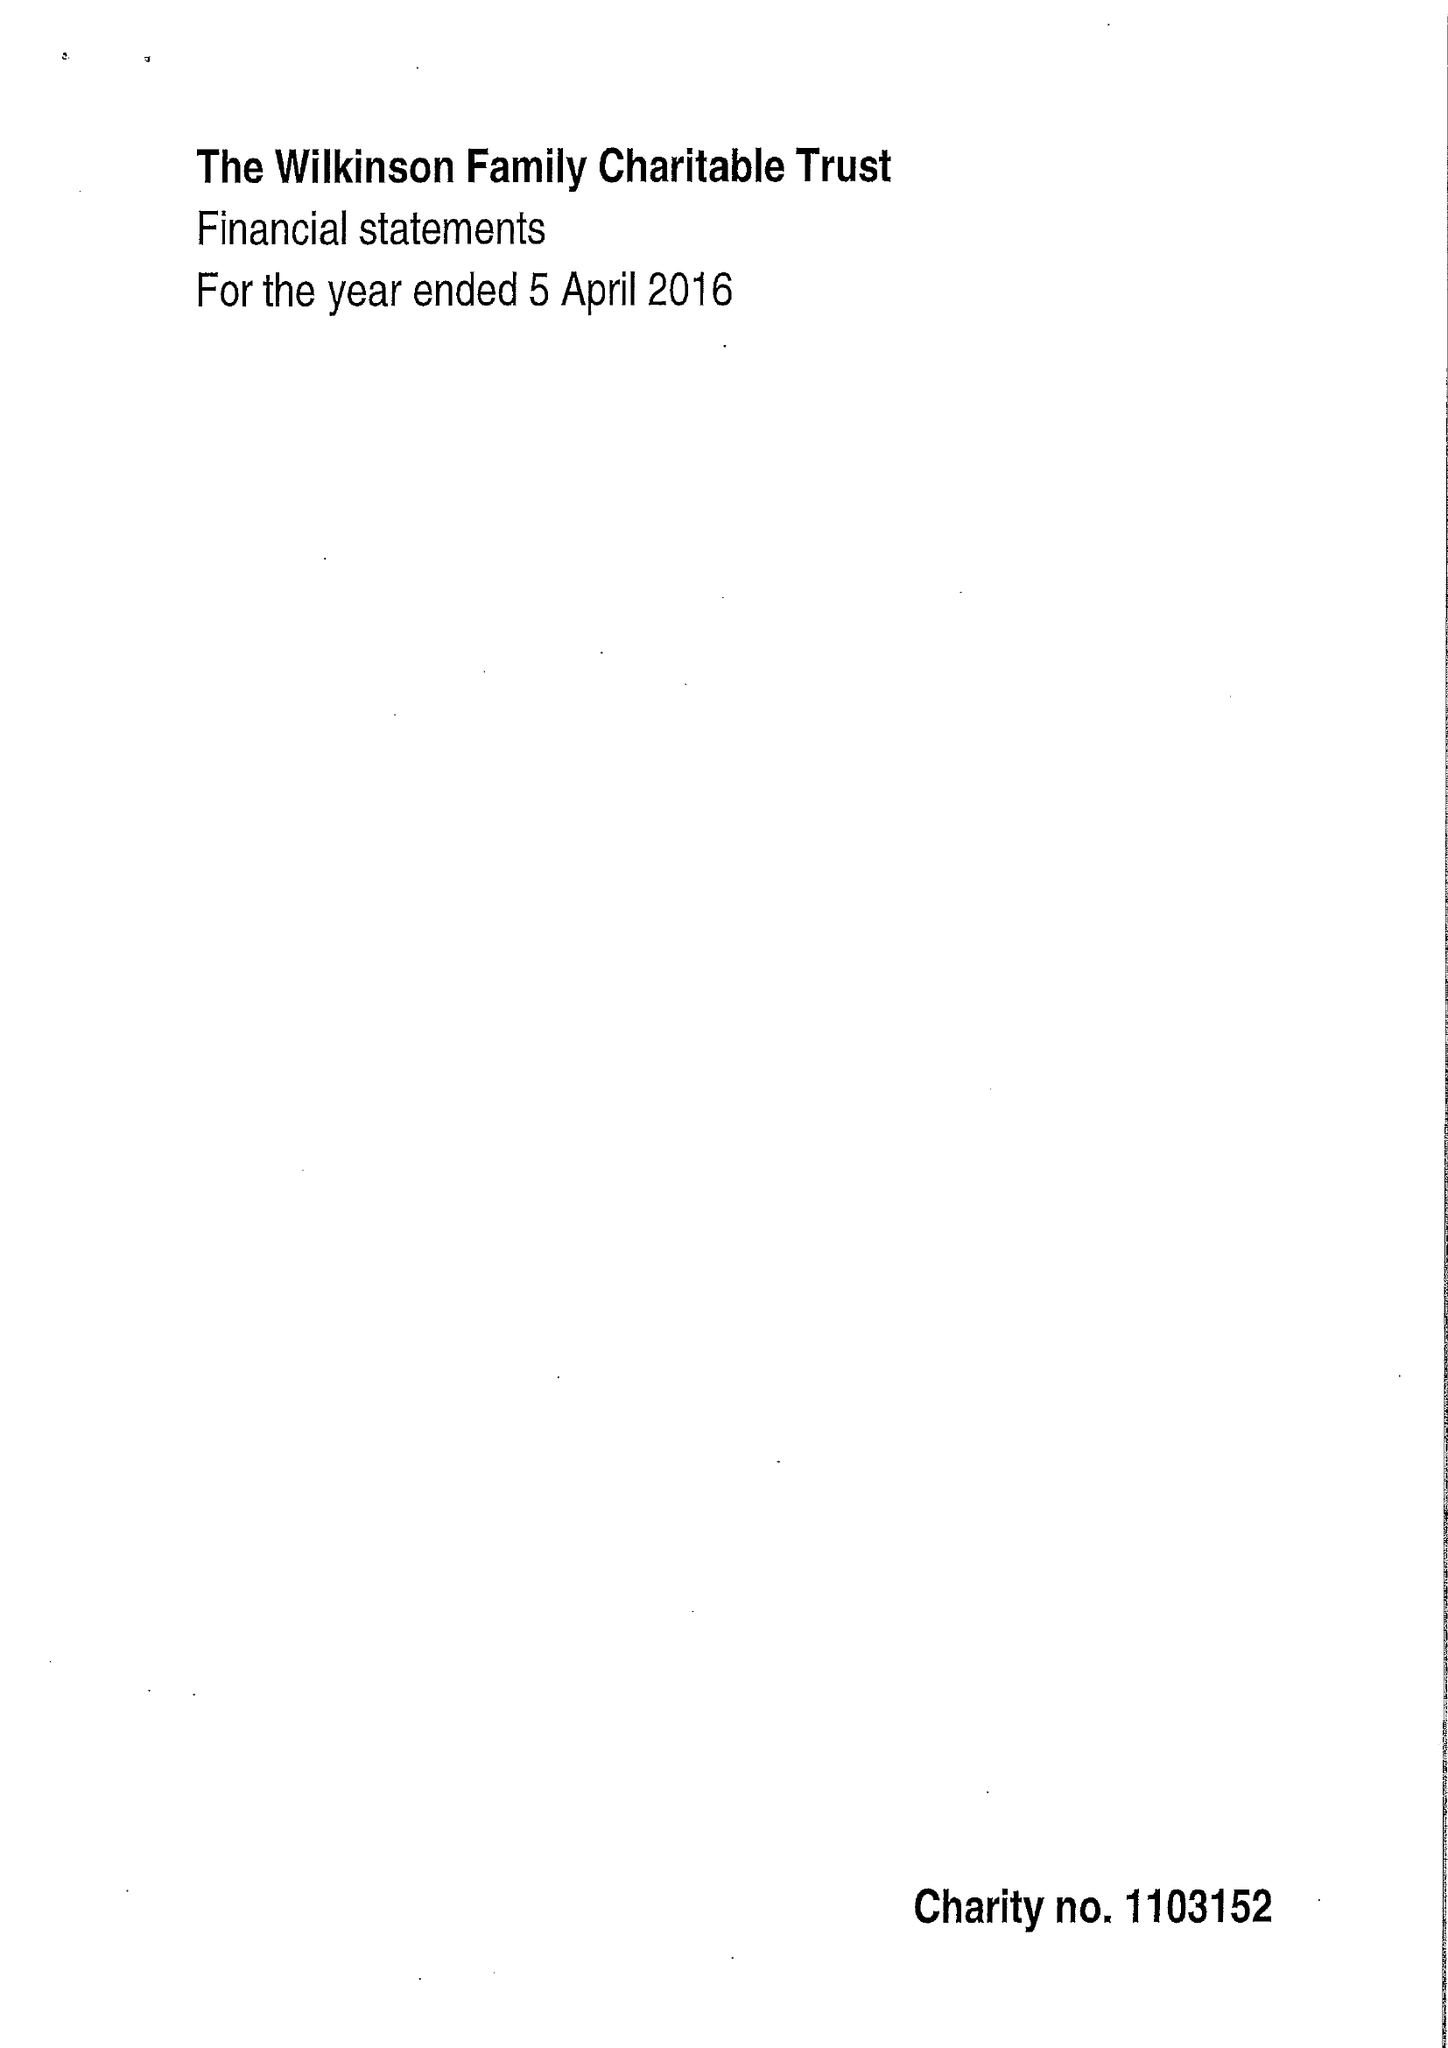What is the value for the address__street_line?
Answer the question using a single word or phrase. CASTLE MEADOW ROAD 